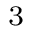<formula> <loc_0><loc_0><loc_500><loc_500>_ { 3 }</formula> 